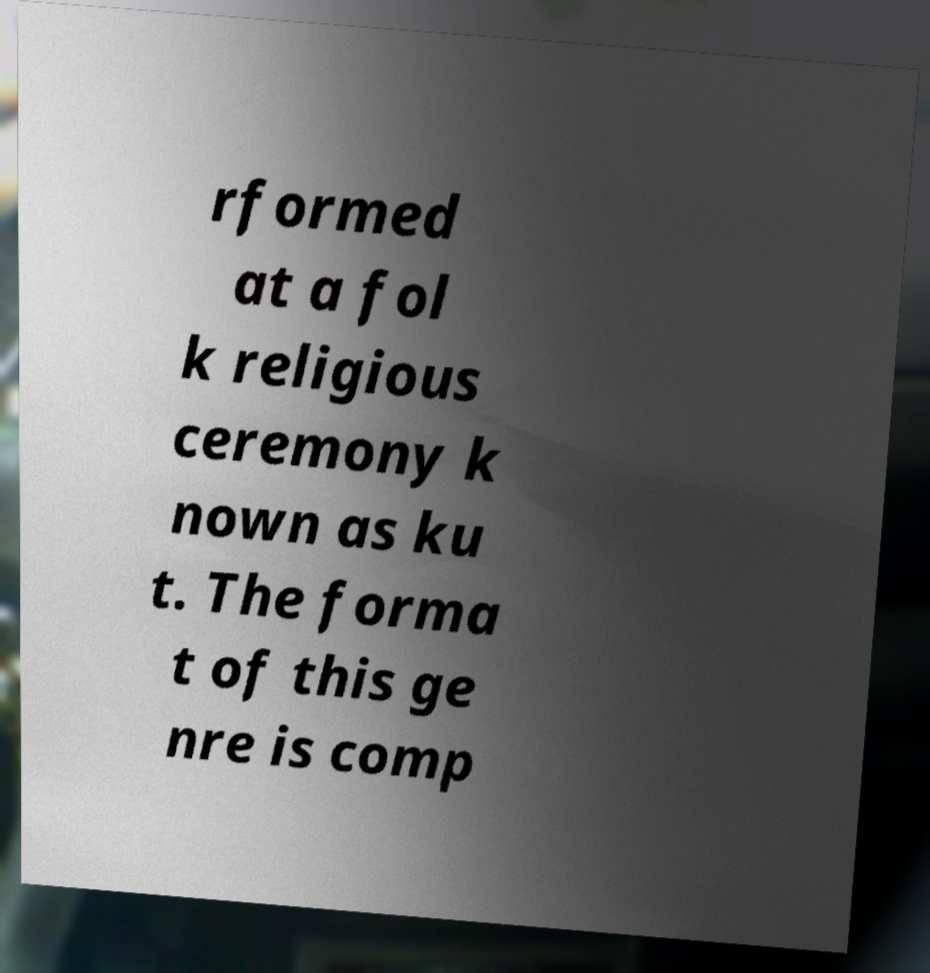Could you assist in decoding the text presented in this image and type it out clearly? rformed at a fol k religious ceremony k nown as ku t. The forma t of this ge nre is comp 